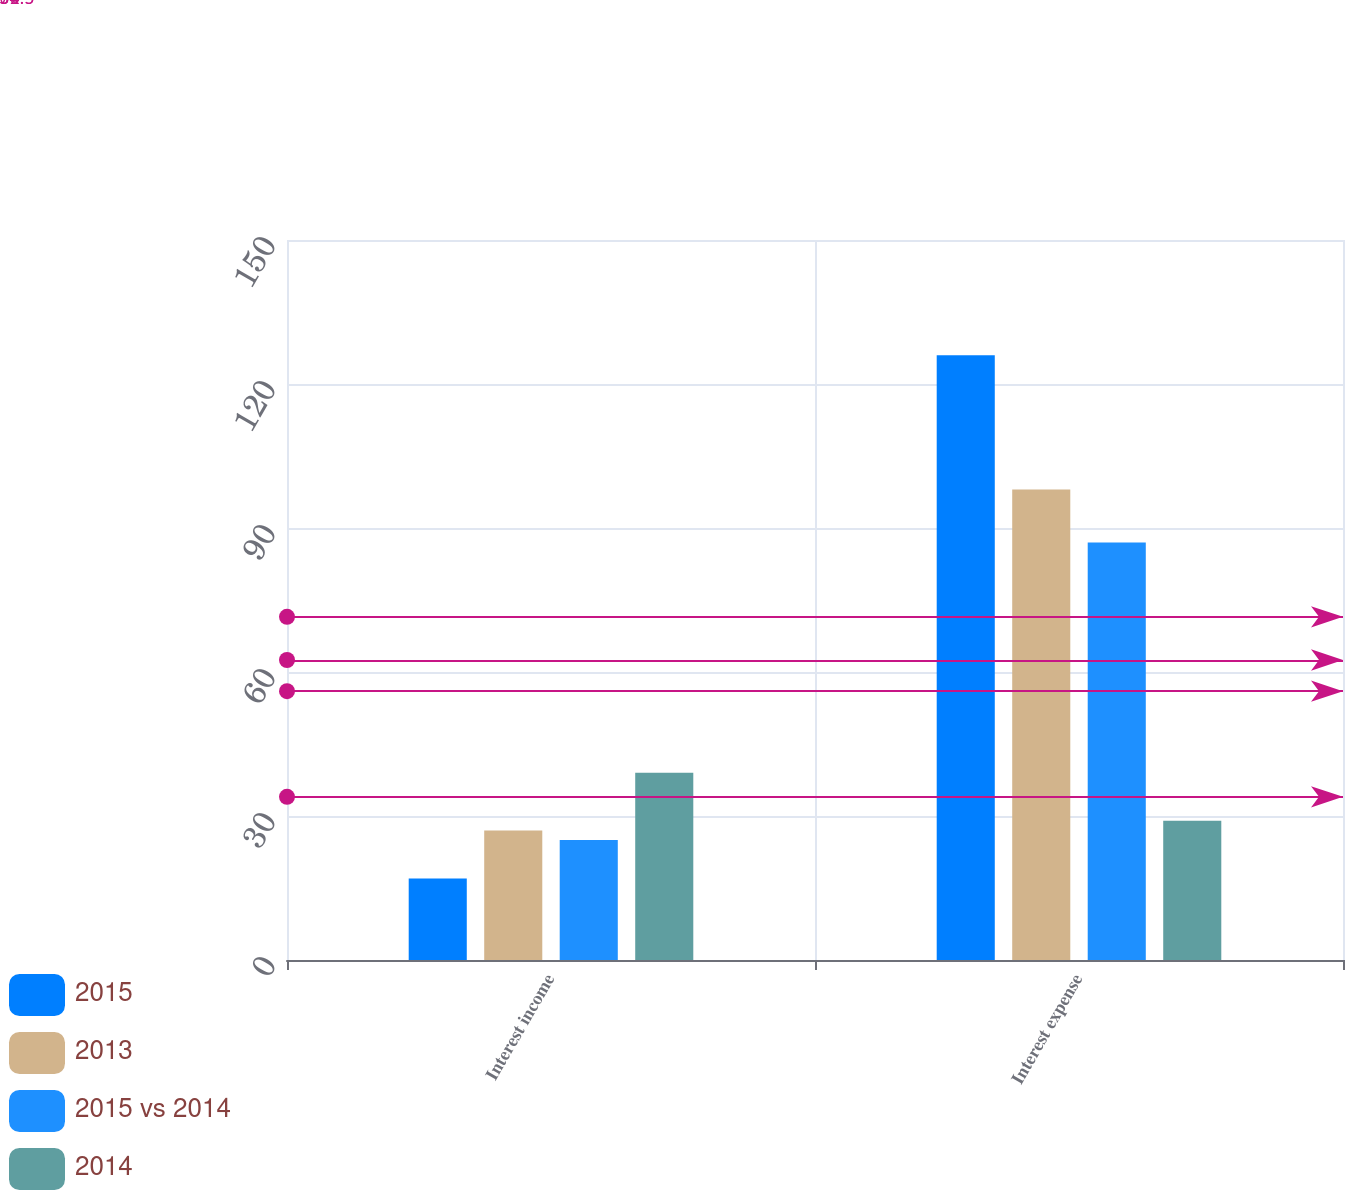Convert chart to OTSL. <chart><loc_0><loc_0><loc_500><loc_500><stacked_bar_chart><ecel><fcel>Interest income<fcel>Interest expense<nl><fcel>2015<fcel>17<fcel>126<nl><fcel>2013<fcel>27<fcel>98<nl><fcel>2015 vs 2014<fcel>25<fcel>87<nl><fcel>2014<fcel>39<fcel>29<nl></chart> 